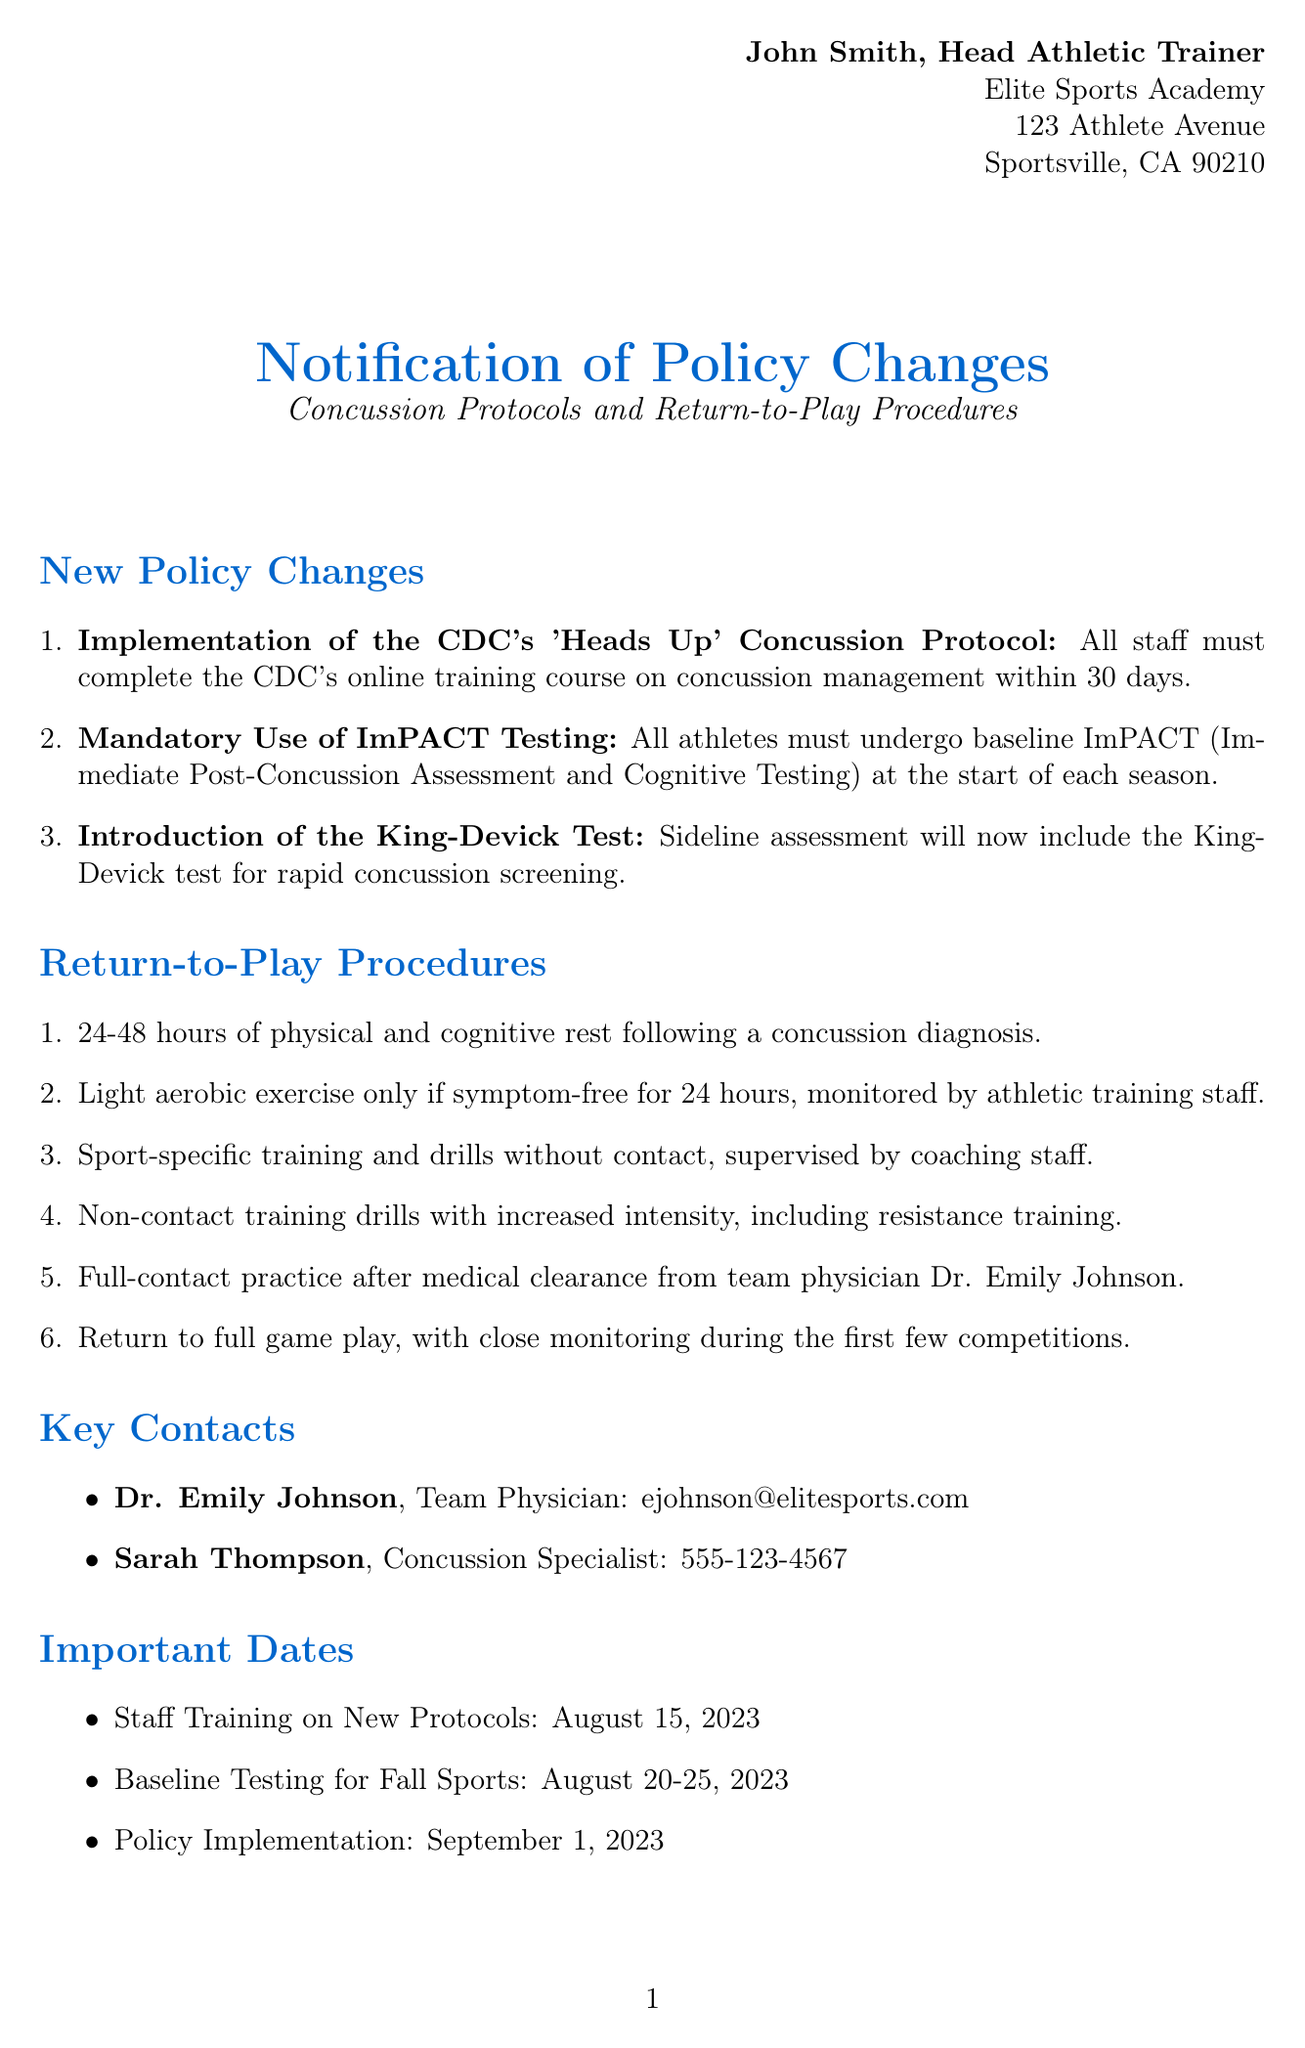what is the name of the Head Athletic Trainer? The name of the Head Athletic Trainer is mentioned at the beginning of the document.
Answer: John Smith what must all staff complete within 30 days? This information is detailed in the policy changes regarding concussion protocols.
Answer: CDC's online training course on concussion management what is the new sideline assessment test being introduced? The document specifies a new test that will be included for concussion screening on the sidelines.
Answer: King-Devick test how long is the initial rest period after a concussion diagnosis? The return-to-play procedures state the duration of rest following a concussion diagnosis.
Answer: 24-48 hours who is the team physician mentioned in the document? The document lists key contacts, specifying the role and name of the team physician.
Answer: Dr. Emily Johnson what is the date for the staff training on new protocols? Important dates are outlined in the document, which mention key events and their dates.
Answer: August 15, 2023 how many steps are in the return-to-play procedures? The document enumerates the steps involved in the return-to-play procedures for athletes.
Answer: 6 steps when does the policy implementation occur? The implementation date is specified among the important dates in the document.
Answer: September 1, 2023 what is the phone number of the concussion specialist? The document provides contact information for key personnel, including a specialist in concussions.
Answer: 555-123-4567 